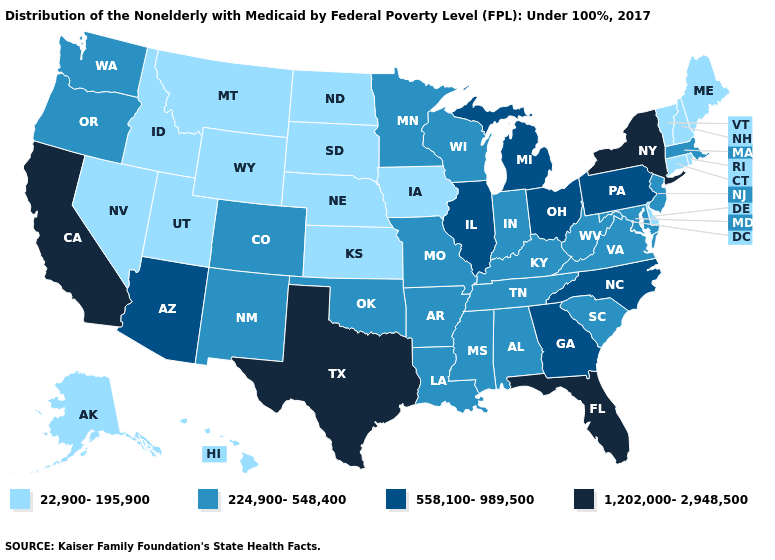Does New Jersey have the highest value in the USA?
Quick response, please. No. What is the value of South Dakota?
Write a very short answer. 22,900-195,900. What is the lowest value in the USA?
Keep it brief. 22,900-195,900. What is the value of Louisiana?
Concise answer only. 224,900-548,400. Does Rhode Island have the highest value in the USA?
Concise answer only. No. Does the map have missing data?
Keep it brief. No. Does West Virginia have a higher value than Idaho?
Keep it brief. Yes. Name the states that have a value in the range 1,202,000-2,948,500?
Answer briefly. California, Florida, New York, Texas. Among the states that border Arkansas , does Texas have the highest value?
Write a very short answer. Yes. What is the highest value in the USA?
Give a very brief answer. 1,202,000-2,948,500. What is the value of Nevada?
Be succinct. 22,900-195,900. What is the value of North Carolina?
Give a very brief answer. 558,100-989,500. How many symbols are there in the legend?
Answer briefly. 4. Does Texas have the highest value in the USA?
Be succinct. Yes. Among the states that border South Carolina , which have the lowest value?
Answer briefly. Georgia, North Carolina. 